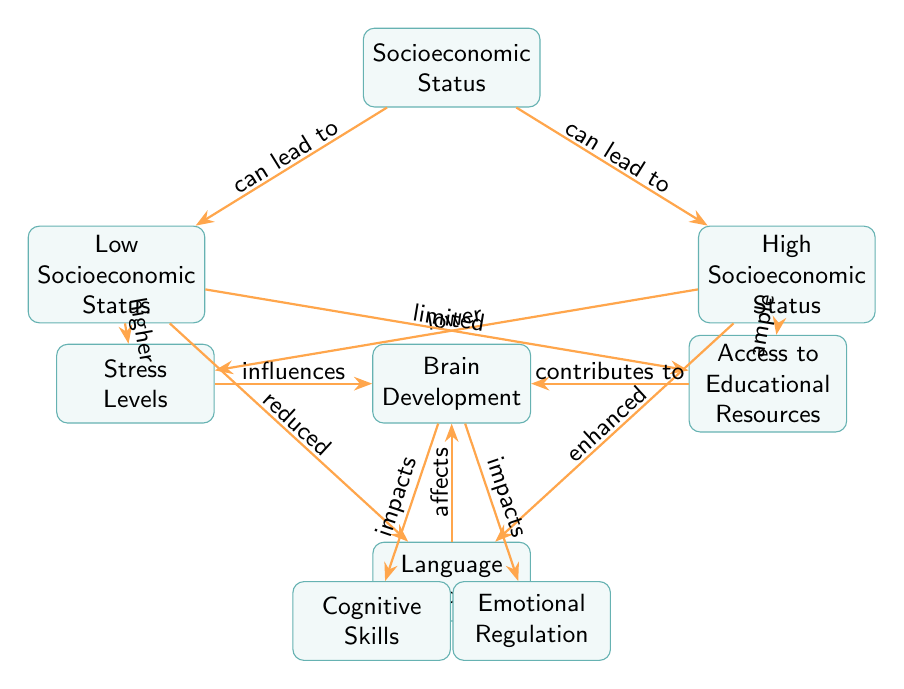What is the primary node in the diagram? The primary node is connected to socioeconomic status and influences brain development, which is seen at the center of the diagram.
Answer: Brain Development How many nodes represent socioeconomic status? The diagram shows two specific nodes that refer to socioeconomic status; one for low and one for high socioeconomic status.
Answer: 2 What effect does low socioeconomic status have on stress levels? The diagram states that low socioeconomic status leads to higher stress levels, as indicated by the direction of the arrow from low socioeconomic status to stress levels.
Answer: Higher What does high socioeconomic status typically provide in terms of educational resources? According to the diagram, high socioeconomic status is associated with ample access to educational resources. This is derived from the connection between high socioeconomic status and resources.
Answer: Ample How do stress levels influence brain development? The diagram indicates that stress levels influence brain development, which can be traced from stress levels to the brain development node.
Answer: Influences What is the relationship between educational resources and brain development? The relationship is that access to educational resources contributes to brain development, which is illustrated by the arrow connecting resources to brain development.
Answer: Contributes to In the context of this diagram, how is language exposure affected by low socioeconomic status? The diagram shows that low socioeconomic status leads to reduced language exposure, evidenced by the directed arrow from low socioeconomic status to language exposure.
Answer: Reduced How do cognitive skills and emotional regulation relate to brain development? Both cognitive skills and emotional regulation are outputs of brain development, illustrated by the arrows showing that brain development impacts both nodes directly.
Answer: Impacts What role does language exposure play in the overall impact on brain development? The diagram specifies that language exposure affects brain development, creating a direct link that enhances our understanding of its importance in the developmental process.
Answer: Affects 